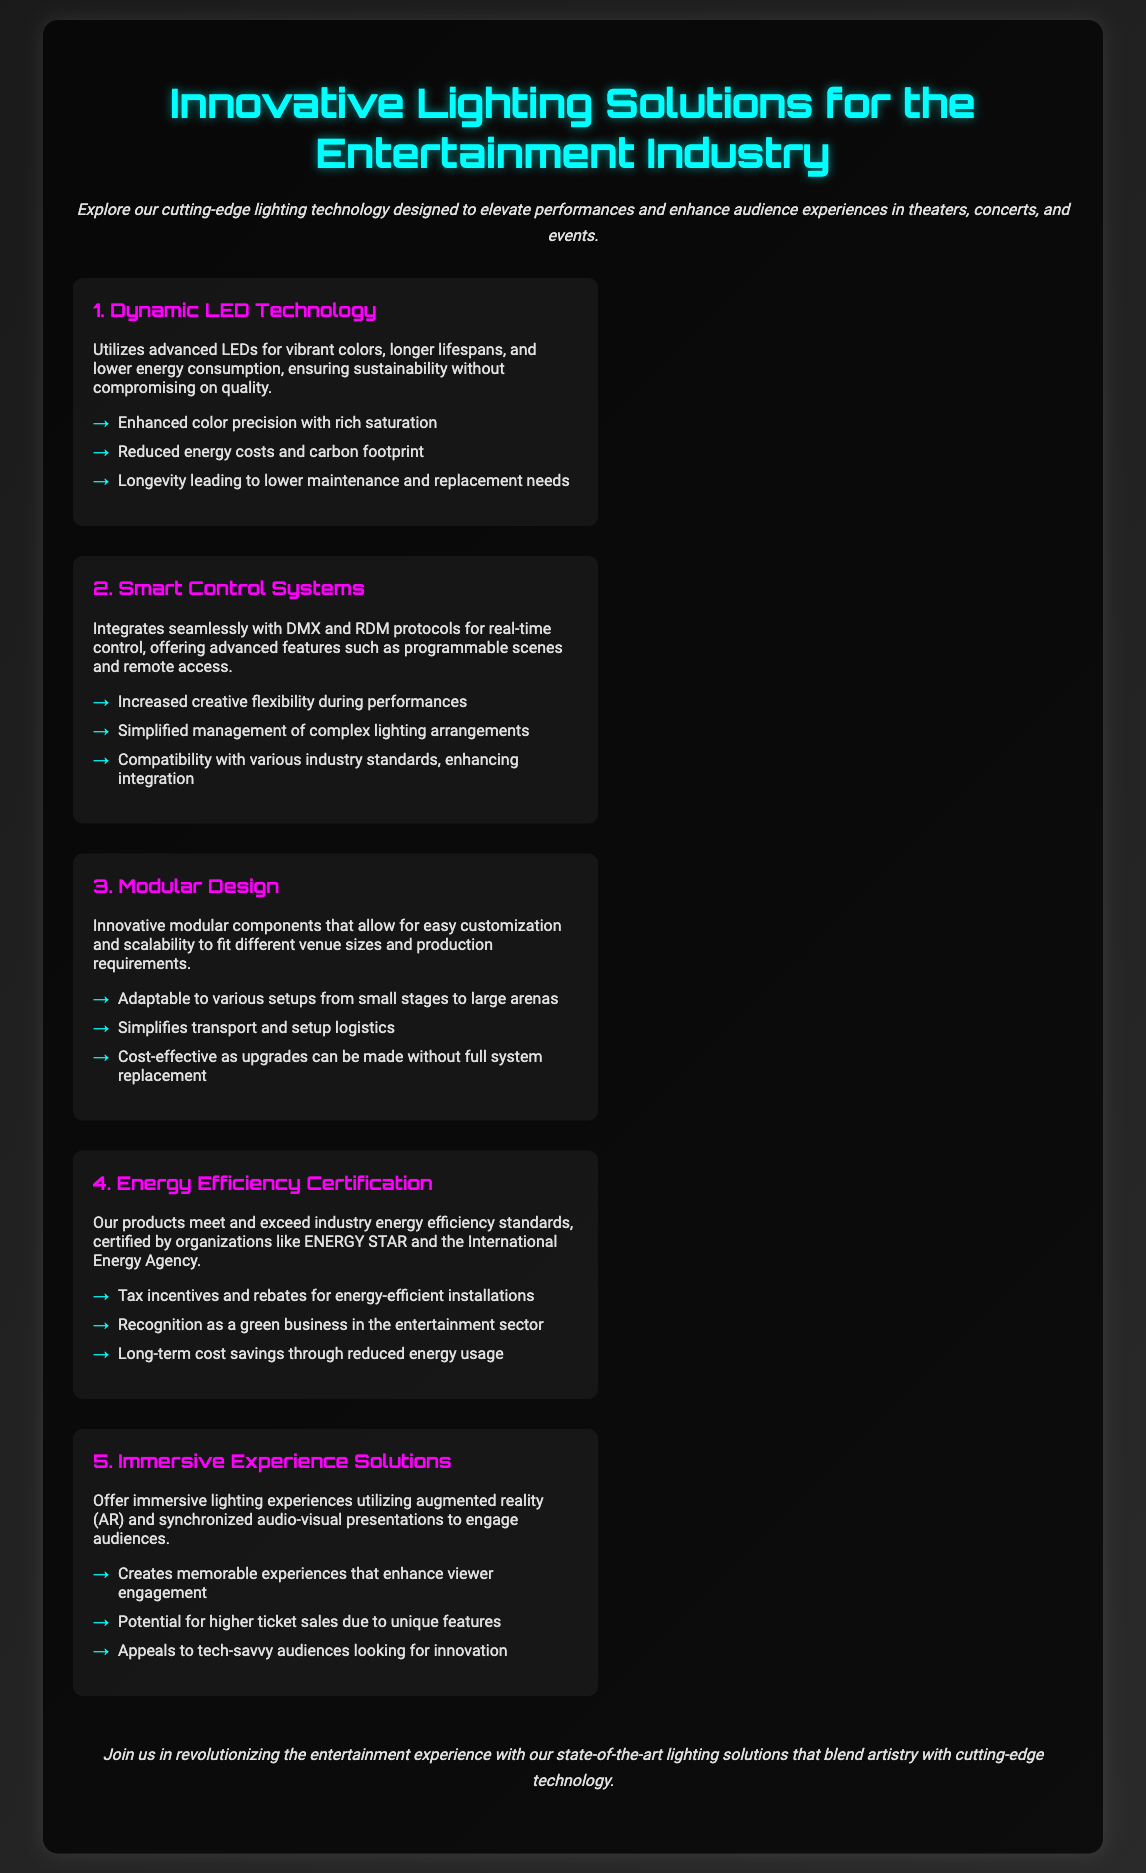What is the title of the brochure? The title of the brochure is presented prominently at the top of the document.
Answer: Innovative Lighting Solutions for the Entertainment Industry How many key features are listed? The document enumerates five distinct features of the innovative lighting solutions.
Answer: 5 What is one benefit of the Dynamic LED Technology? The benefits of Dynamic LED Technology are listed in bullet points, highlighting specific advantages.
Answer: Enhanced color precision with rich saturation What certification does the Energy Efficiency feature mention? The document states the products are certified by notable organizations regarding energy efficiency.
Answer: ENERGY STAR What kind of experience do the Immersive Experience Solutions offer? The document describes how this feature engages the audience through specific technological integrations.
Answer: Immersive lighting experiences Which feature allows for customization and scalability? The brochure explicitly points out a feature that is designed for flexibility and fit across various venues.
Answer: Modular Design What color is used for the headings of features? The document uses a specific color to highlight the headings for visual emphasis.
Answer: Magenta What is the final call to action in the document? The conclusion summarizes the purpose of the brochure and encourages a specific action regarding the lighting solutions.
Answer: Join us in revolutionizing the entertainment experience 